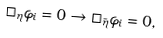<formula> <loc_0><loc_0><loc_500><loc_500>\Box _ { \eta } \varphi _ { i } = 0 \rightarrow \Box _ { \bar { \eta } } \varphi _ { i } = 0 ,</formula> 